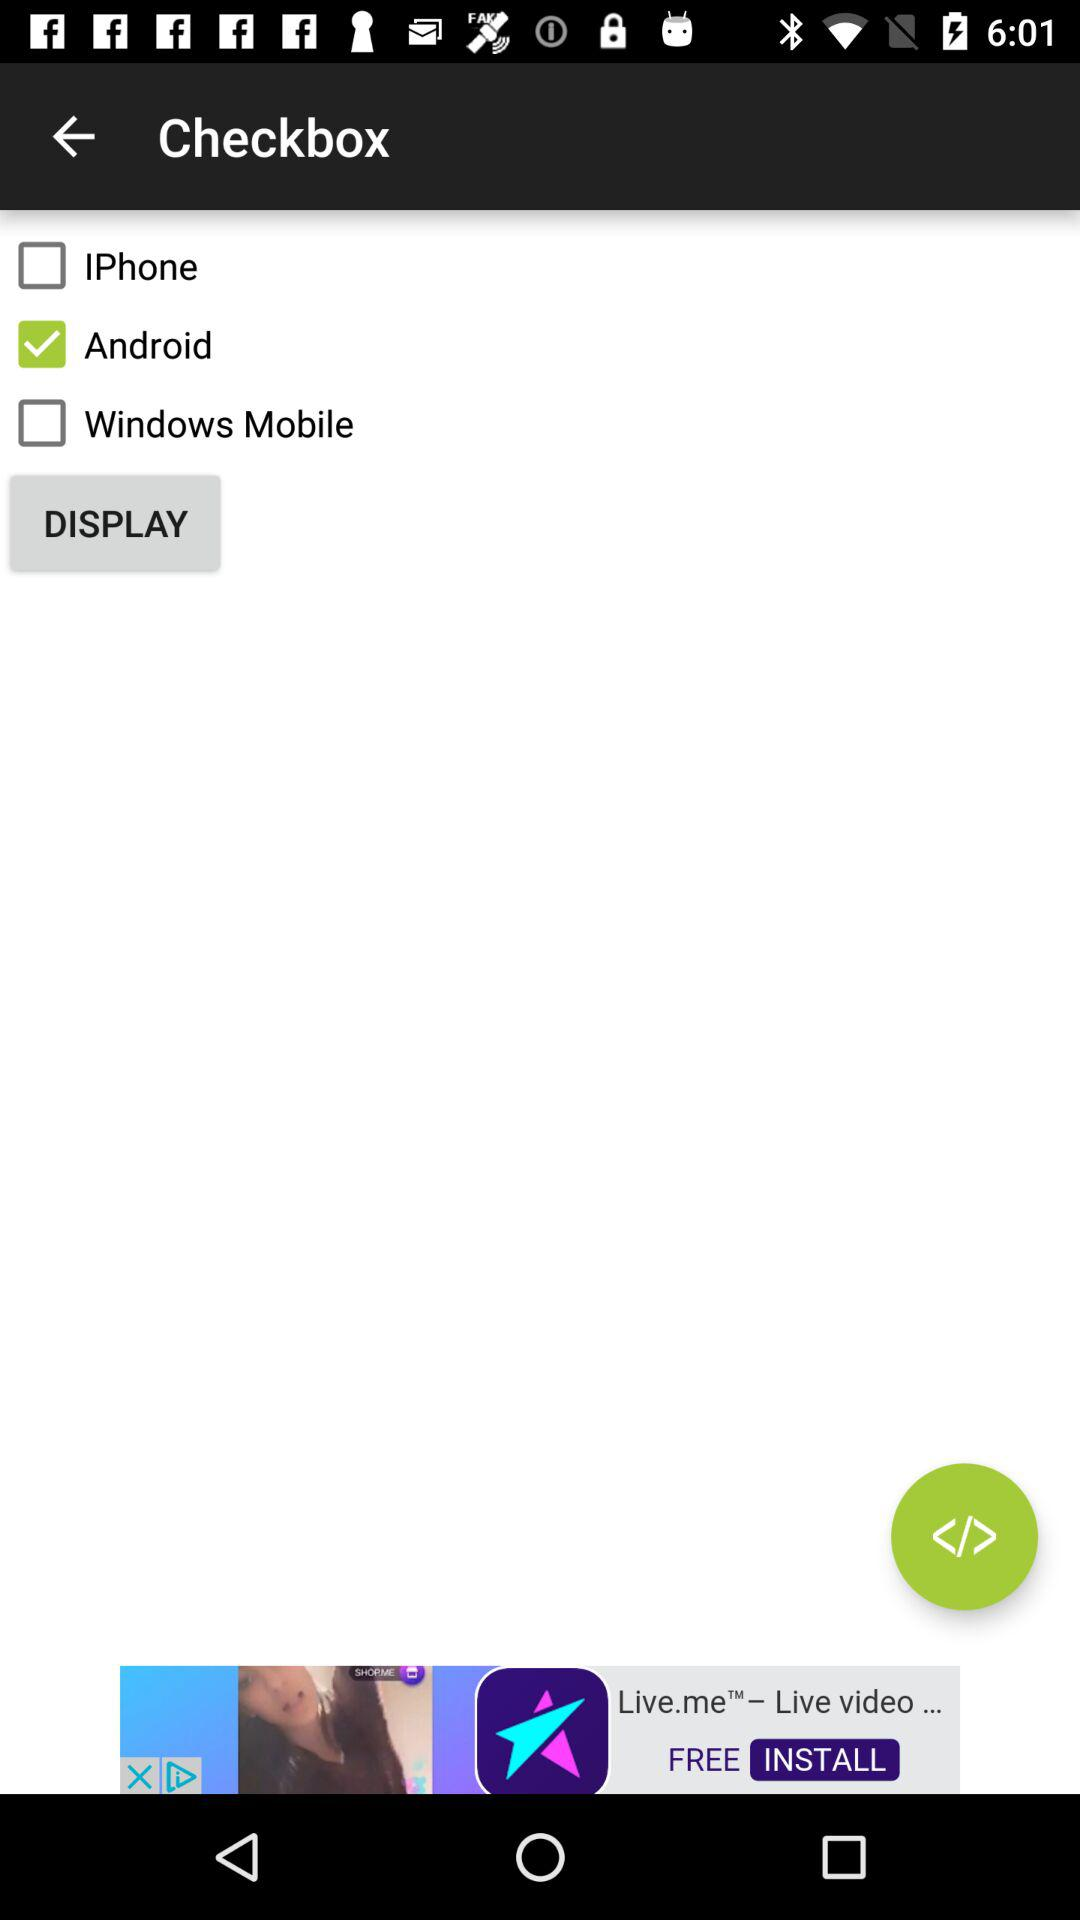How many checkboxes are unchecked? 2 